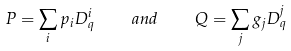<formula> <loc_0><loc_0><loc_500><loc_500>P = \sum _ { i } p _ { i } D ^ { i } _ { q } \quad a n d \quad Q = \sum _ { j } g _ { j } D ^ { j } _ { q }</formula> 